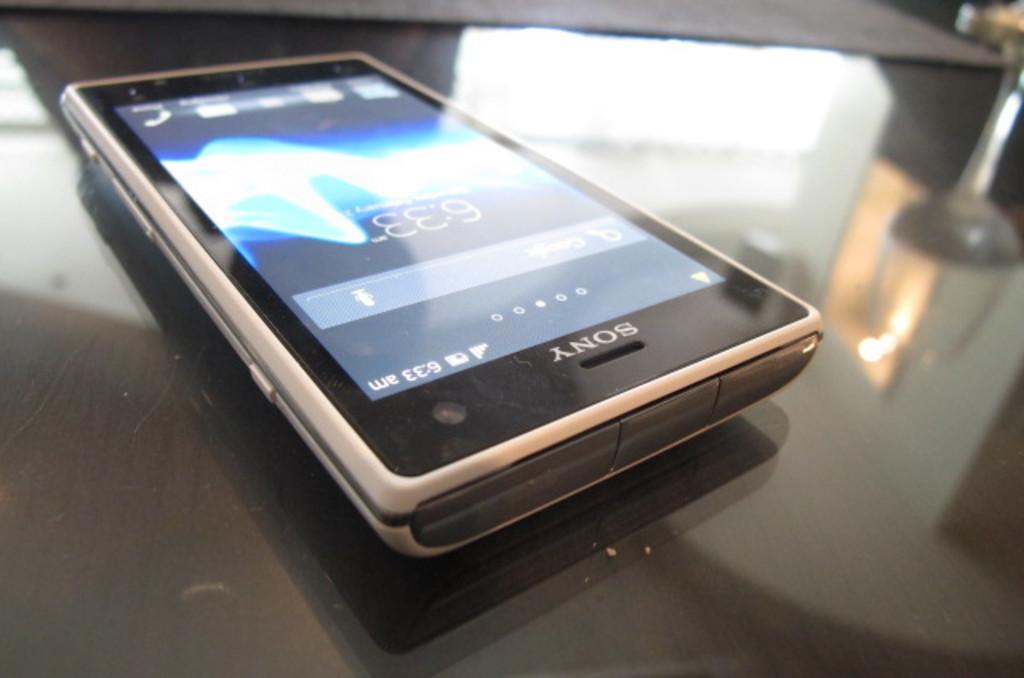<image>
Summarize the visual content of the image. A Sony cell phone sits on a shiny black table. 